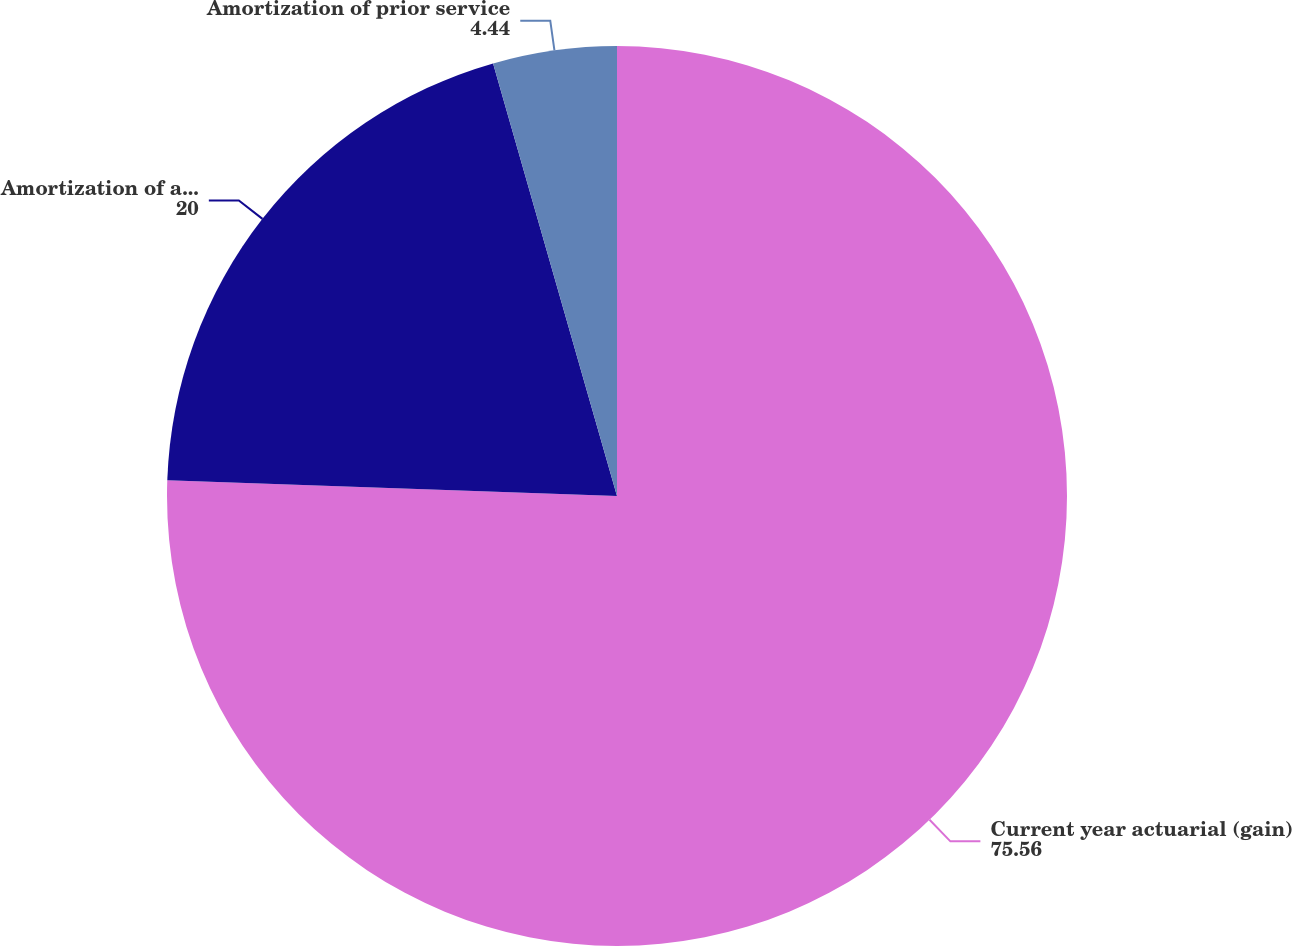Convert chart. <chart><loc_0><loc_0><loc_500><loc_500><pie_chart><fcel>Current year actuarial (gain)<fcel>Amortization of actuarial<fcel>Amortization of prior service<nl><fcel>75.56%<fcel>20.0%<fcel>4.44%<nl></chart> 